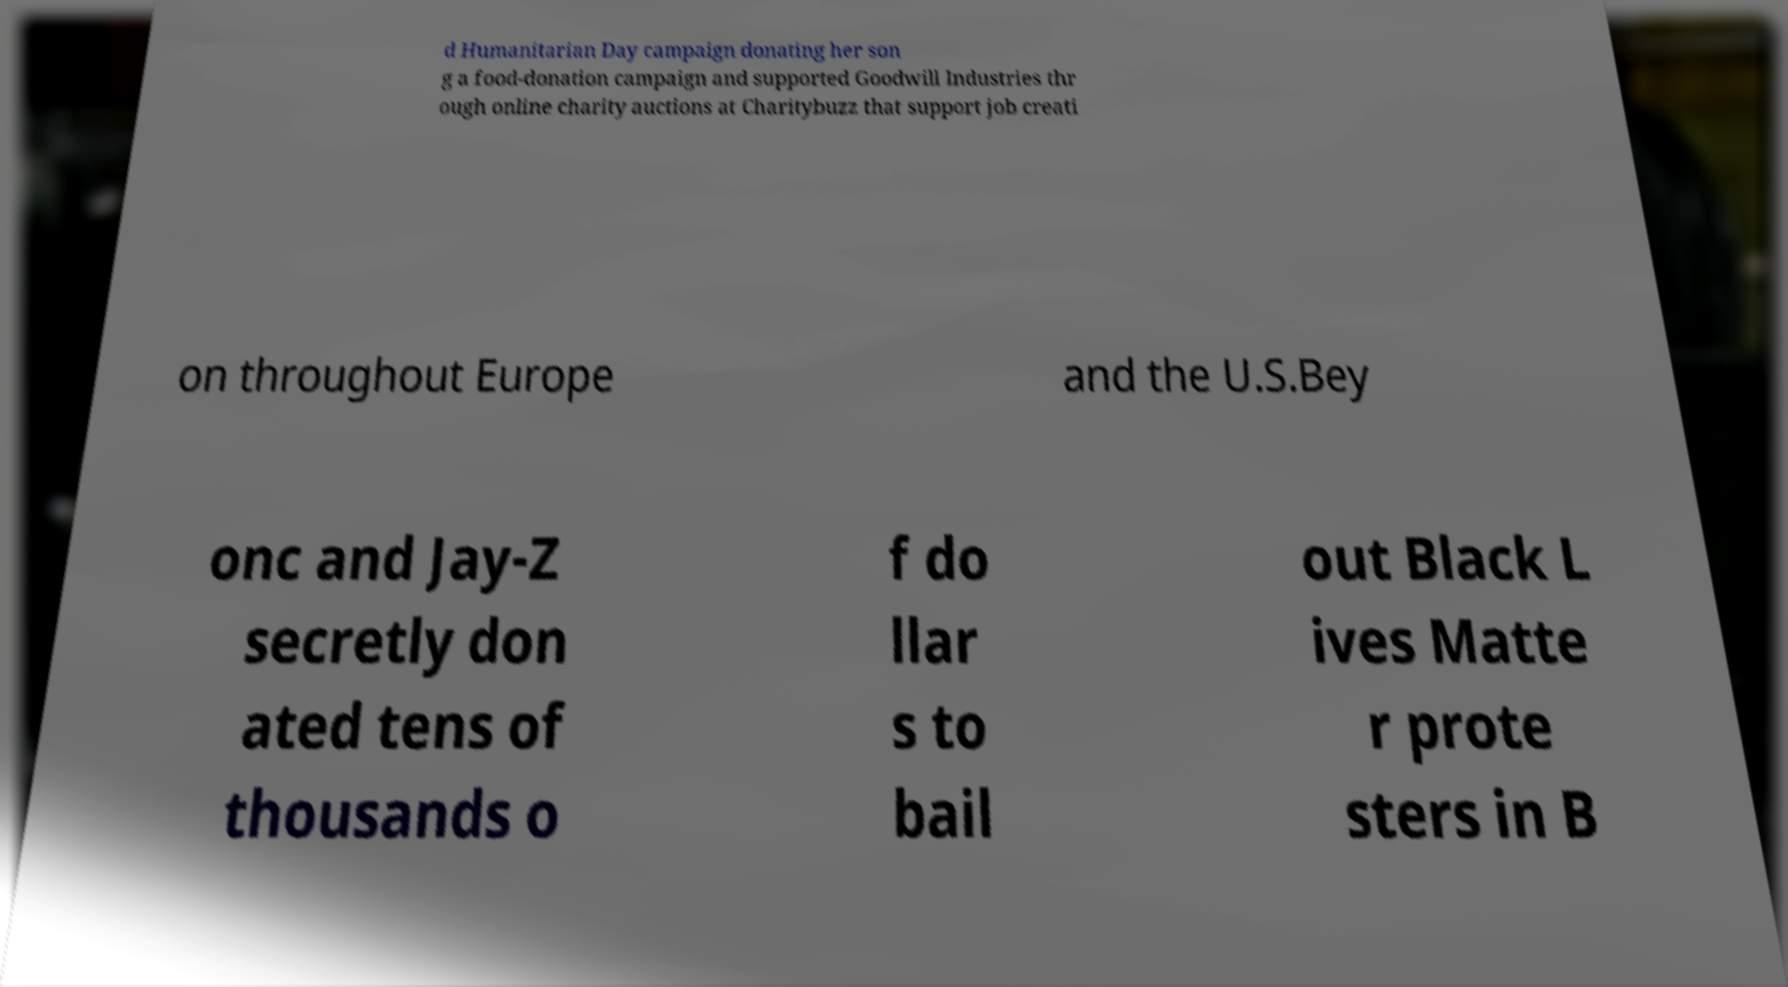What messages or text are displayed in this image? I need them in a readable, typed format. d Humanitarian Day campaign donating her son g a food-donation campaign and supported Goodwill Industries thr ough online charity auctions at Charitybuzz that support job creati on throughout Europe and the U.S.Bey onc and Jay-Z secretly don ated tens of thousands o f do llar s to bail out Black L ives Matte r prote sters in B 